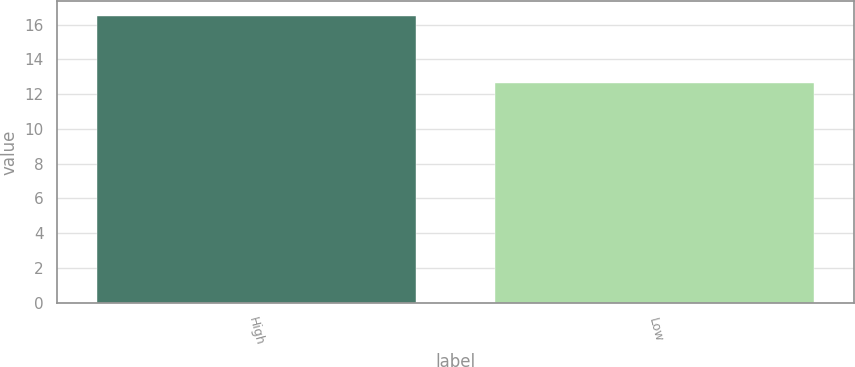<chart> <loc_0><loc_0><loc_500><loc_500><bar_chart><fcel>High<fcel>Low<nl><fcel>16.5<fcel>12.65<nl></chart> 